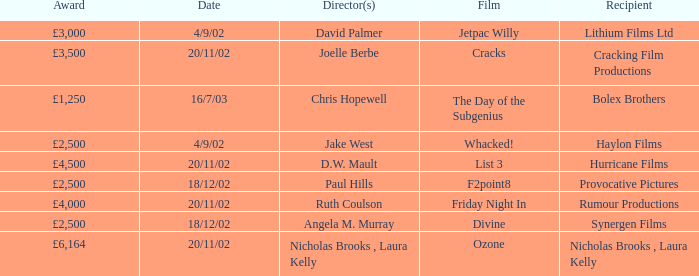Can you give me this table as a dict? {'header': ['Award', 'Date', 'Director(s)', 'Film', 'Recipient'], 'rows': [['£3,000', '4/9/02', 'David Palmer', 'Jetpac Willy', 'Lithium Films Ltd'], ['£3,500', '20/11/02', 'Joelle Berbe', 'Cracks', 'Cracking Film Productions'], ['£1,250', '16/7/03', 'Chris Hopewell', 'The Day of the Subgenius', 'Bolex Brothers'], ['£2,500', '4/9/02', 'Jake West', 'Whacked!', 'Haylon Films'], ['£4,500', '20/11/02', 'D.W. Mault', 'List 3', 'Hurricane Films'], ['£2,500', '18/12/02', 'Paul Hills', 'F2point8', 'Provocative Pictures'], ['£4,000', '20/11/02', 'Ruth Coulson', 'Friday Night In', 'Rumour Productions'], ['£2,500', '18/12/02', 'Angela M. Murray', 'Divine', 'Synergen Films'], ['£6,164', '20/11/02', 'Nicholas Brooks , Laura Kelly', 'Ozone', 'Nicholas Brooks , Laura Kelly']]} Who directed a film for Cracking Film Productions? Joelle Berbe. 